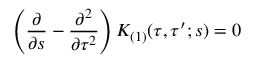<formula> <loc_0><loc_0><loc_500><loc_500>\left ( \frac { \partial } { \partial s } - \frac { \partial ^ { 2 } } { \partial \tau ^ { 2 } } \right ) K _ { ( 1 ) } ( \tau , \tau ^ { \prime } ; s ) = 0</formula> 